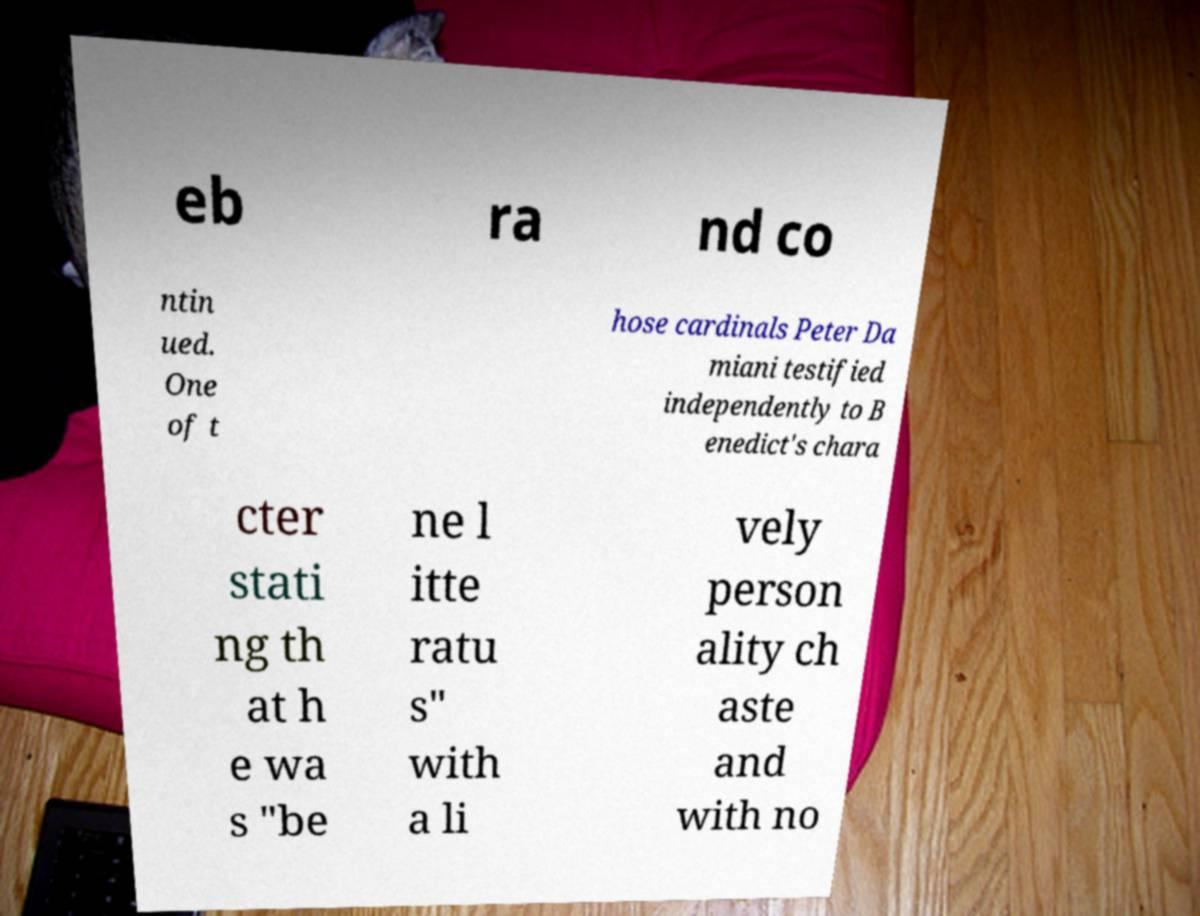Can you accurately transcribe the text from the provided image for me? eb ra nd co ntin ued. One of t hose cardinals Peter Da miani testified independently to B enedict's chara cter stati ng th at h e wa s "be ne l itte ratu s" with a li vely person ality ch aste and with no 